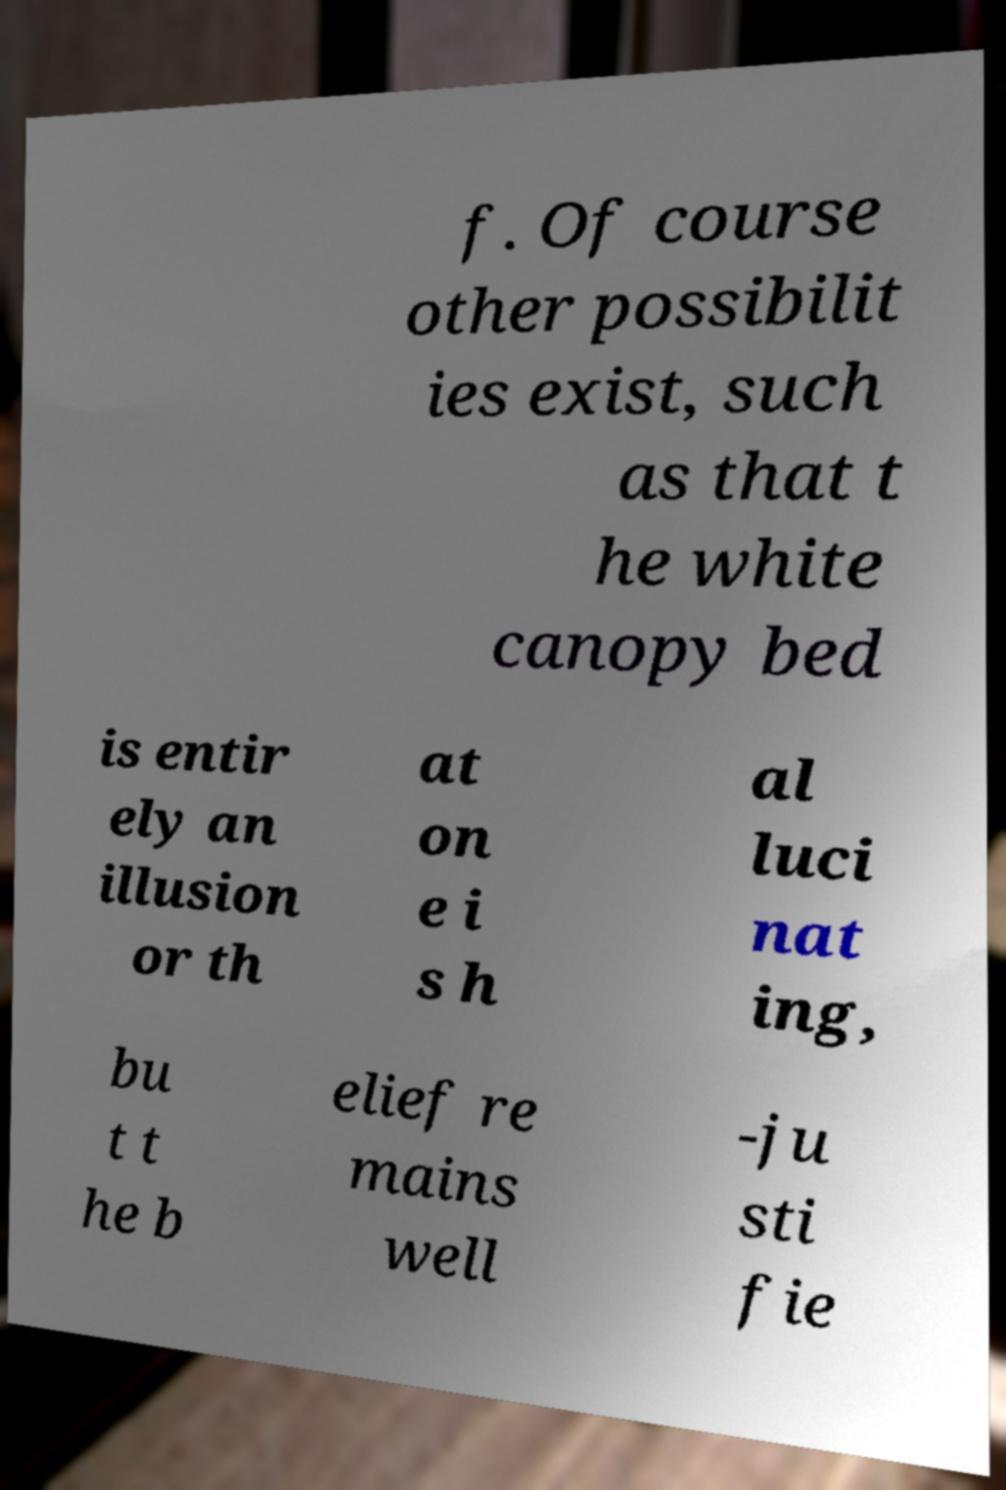Can you read and provide the text displayed in the image?This photo seems to have some interesting text. Can you extract and type it out for me? f. Of course other possibilit ies exist, such as that t he white canopy bed is entir ely an illusion or th at on e i s h al luci nat ing, bu t t he b elief re mains well -ju sti fie 